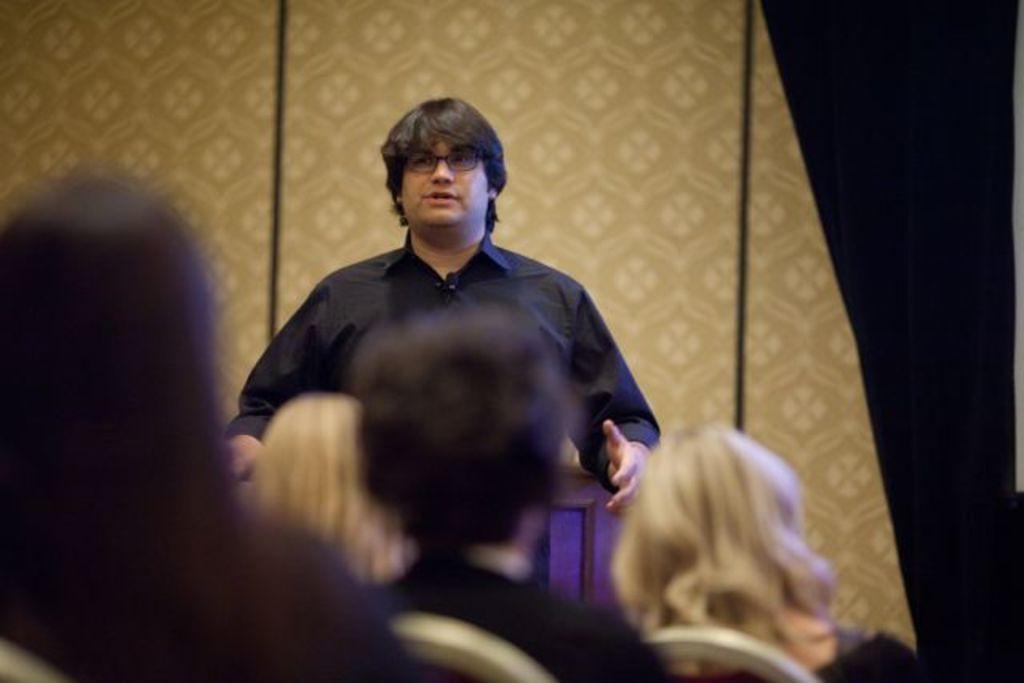Describe this image in one or two sentences. In this picture there is a person standing and talking. In the foreground there are group of people sitting on the chairs. At the back it looks like a wall. 